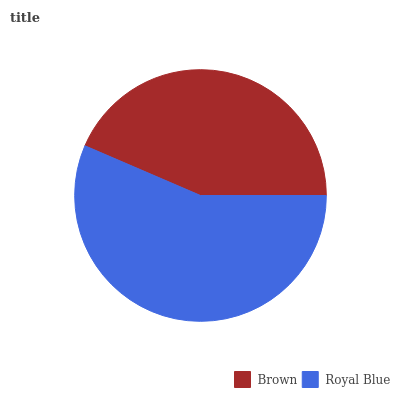Is Brown the minimum?
Answer yes or no. Yes. Is Royal Blue the maximum?
Answer yes or no. Yes. Is Royal Blue the minimum?
Answer yes or no. No. Is Royal Blue greater than Brown?
Answer yes or no. Yes. Is Brown less than Royal Blue?
Answer yes or no. Yes. Is Brown greater than Royal Blue?
Answer yes or no. No. Is Royal Blue less than Brown?
Answer yes or no. No. Is Royal Blue the high median?
Answer yes or no. Yes. Is Brown the low median?
Answer yes or no. Yes. Is Brown the high median?
Answer yes or no. No. Is Royal Blue the low median?
Answer yes or no. No. 